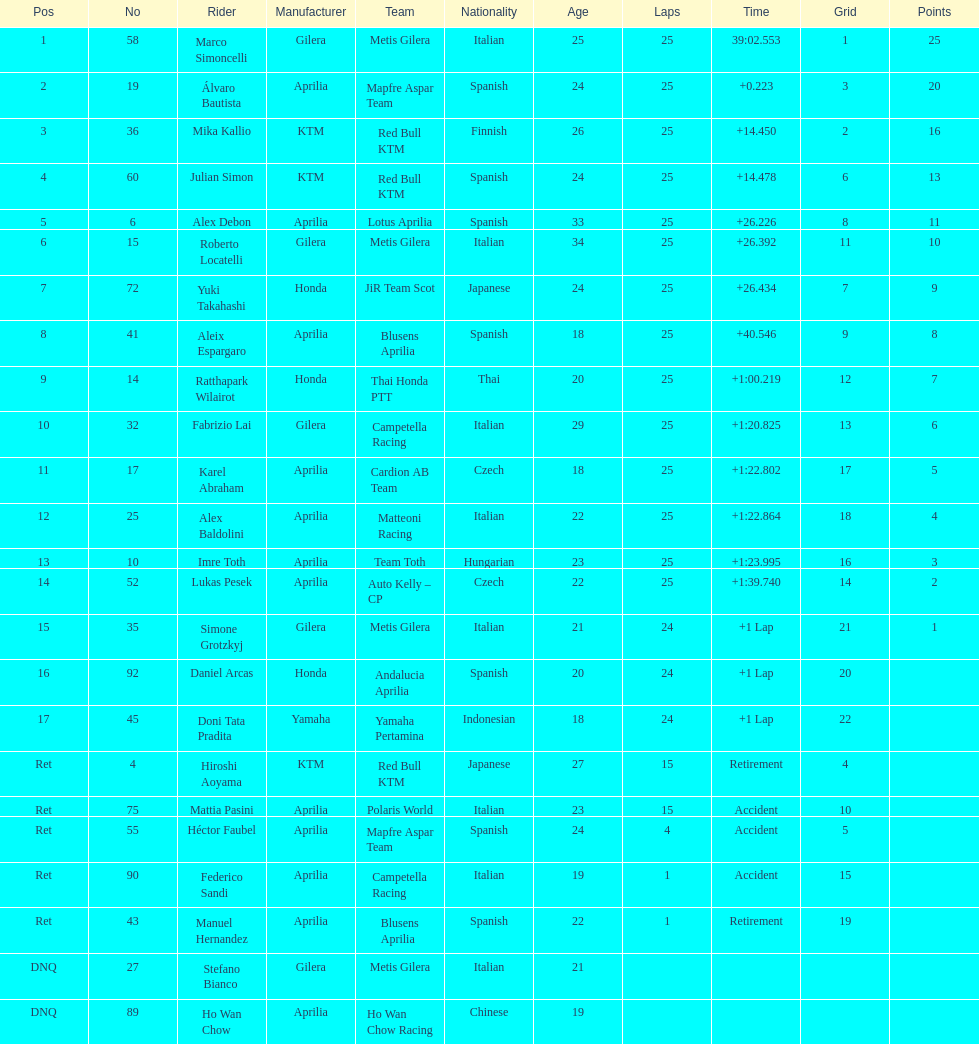What is the total number of laps performed by rider imre toth? 25. 